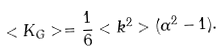<formula> <loc_0><loc_0><loc_500><loc_500>< K _ { G } > = \frac { 1 } { 6 } < k ^ { 2 } > ( \alpha ^ { 2 } - 1 ) .</formula> 